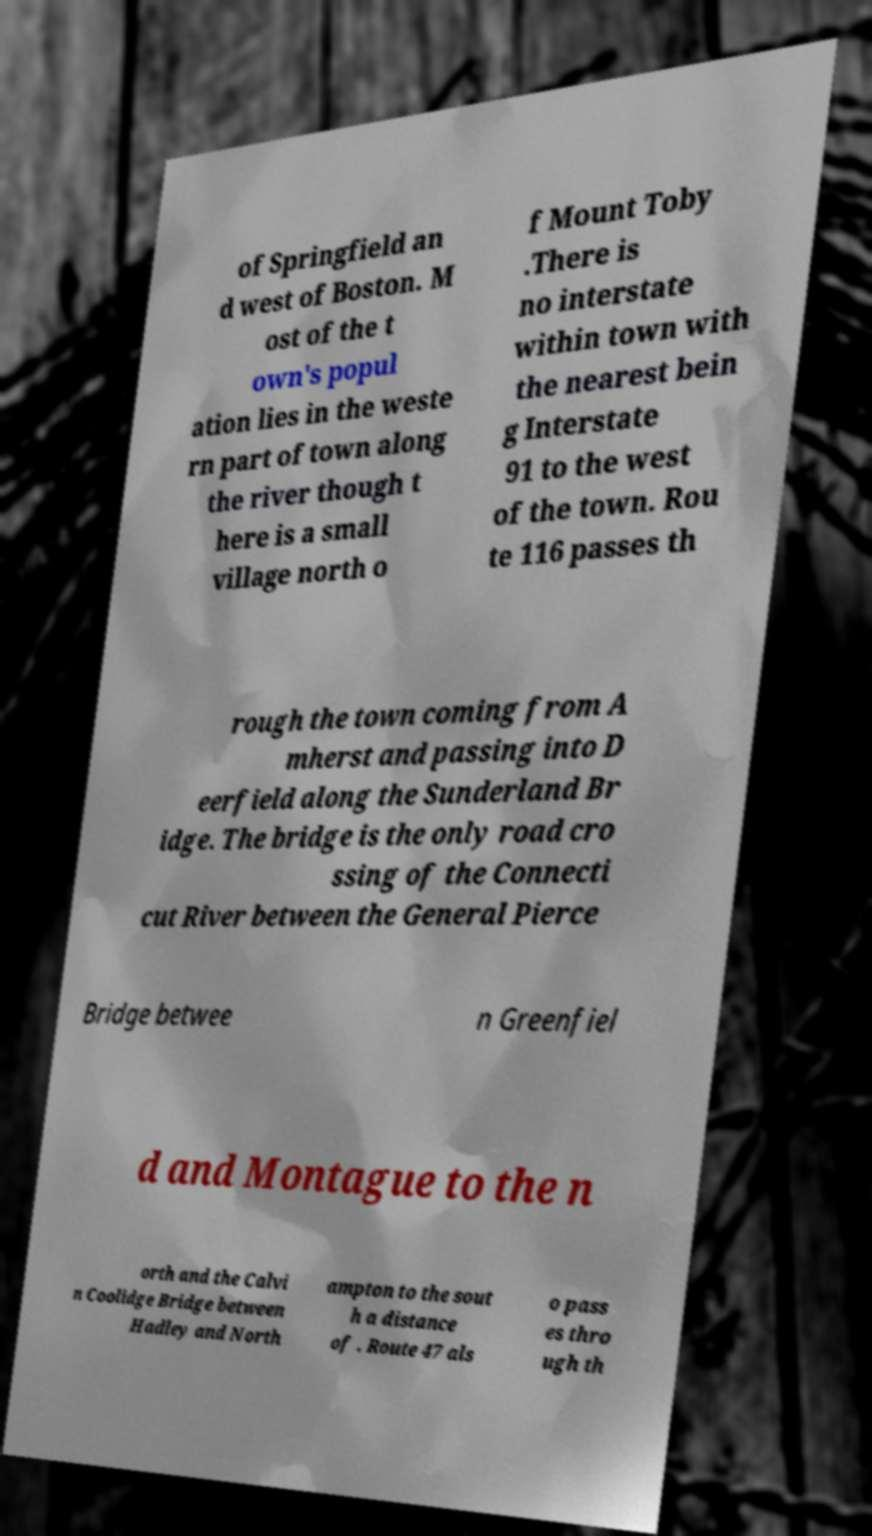Could you assist in decoding the text presented in this image and type it out clearly? of Springfield an d west of Boston. M ost of the t own's popul ation lies in the weste rn part of town along the river though t here is a small village north o f Mount Toby .There is no interstate within town with the nearest bein g Interstate 91 to the west of the town. Rou te 116 passes th rough the town coming from A mherst and passing into D eerfield along the Sunderland Br idge. The bridge is the only road cro ssing of the Connecti cut River between the General Pierce Bridge betwee n Greenfiel d and Montague to the n orth and the Calvi n Coolidge Bridge between Hadley and North ampton to the sout h a distance of . Route 47 als o pass es thro ugh th 